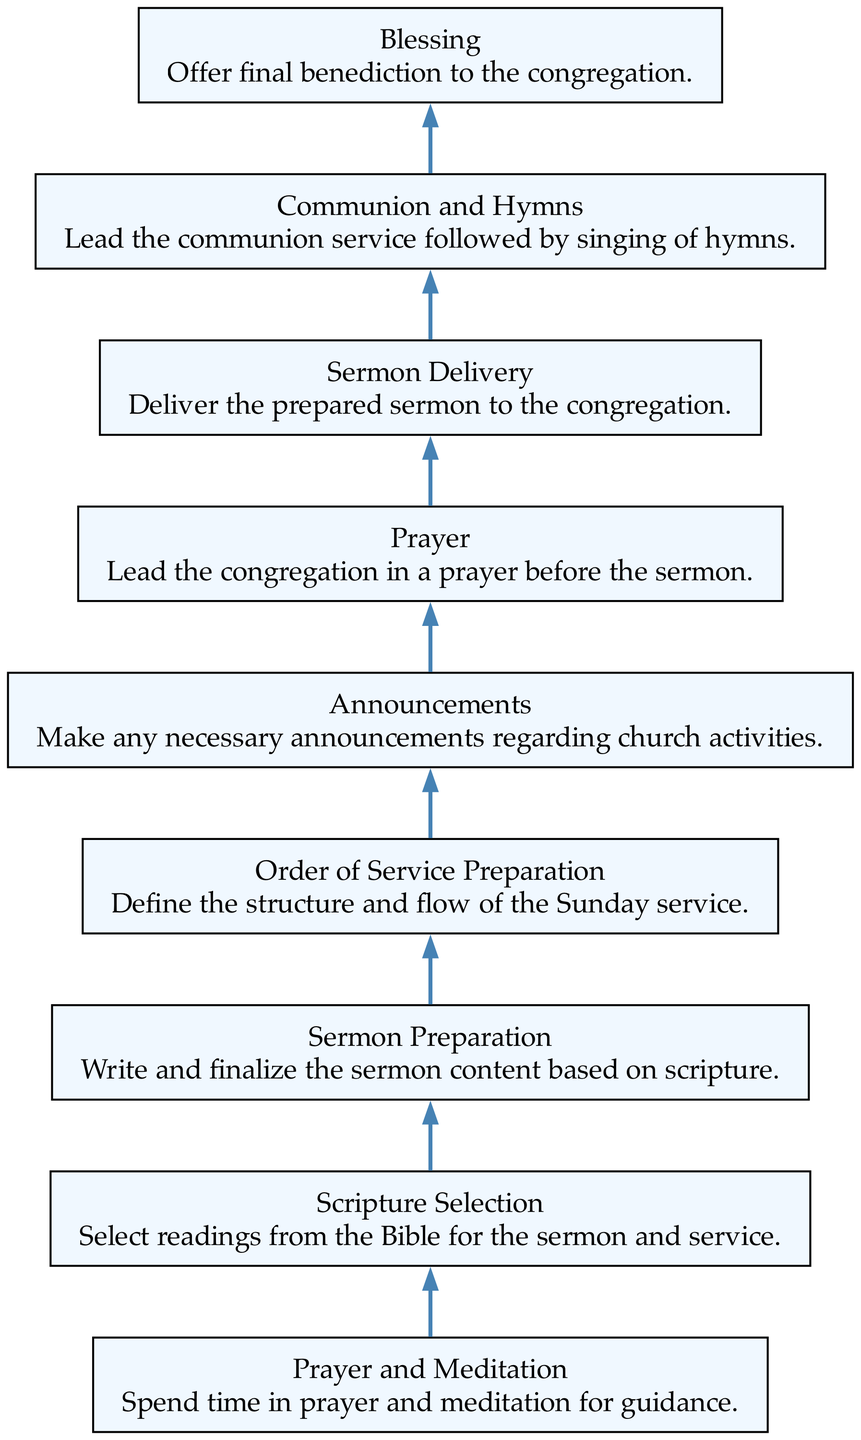What is the final stage in the preparation process? The diagram shows the stages of the Sunday Service Preparation, and the last node at the bottom indicates "Blessing." This is where the final benediction is offered to the congregation.
Answer: Blessing How many stages are listed in the diagram? By counting the nodes in the diagram from "Blessing" to "Prayer and Meditation," there are a total of 9 distinct stages included, indicating a clear flow of tasks.
Answer: 9 What task is associated with the "Sermon Delivery"? The diagram clearly outlines that during the "Sermon Delivery" stage, the task is to "Deliver the prepared sermon to the congregation." This direct relationship is indicated within the node for that stage.
Answer: Deliver the prepared sermon to the congregation What comes before the "Communion and Hymns"? In the flow of the diagram, the "Sermon Delivery" stage logically precedes the "Communion and Hymns" stage, showing the sequence of actions leading up to the music and communion after the sermon.
Answer: Sermon Delivery What is the purpose of "Order of Service Preparation"? The diagram specifies that "Order of Service Preparation" involves defining the structure and flow of the Sunday service, which is crucial for organizing the overall service effectively.
Answer: Define the structure and flow of the Sunday service Which task involves selecting Bible readings? By examining the stages in the diagram, it is clear that the "Scripture Selection" stage is specifically focused on selecting the readings from the Bible for the sermon and the service.
Answer: Select readings from the Bible for the sermon and service What is the step that follows "Prayer and Meditation"? The flow indicates that after the "Prayer and Meditation" stage, the next step is "Scripture Selection," illustrating the transition from personal reflection to the preparation of scripture readings.
Answer: Scripture Selection What is the relationship between "Prayer" and "Sermon Delivery"? The diagram shows that "Prayer" is positioned directly before "Sermon Delivery," which signifies that leading a prayer is a preparatory step that occurs to prepare the congregation for the sermon that will follow.
Answer: "Prayer" directly precedes "Sermon Delivery." How does "Announcements" fit into the service preparation? According to the diagram, "Announcements" is a dedicated stage where necessary information is communicated to the congregation regarding upcoming church activities, reflecting its significance in maintaining community knowledge and involvement.
Answer: Make any necessary announcements regarding church activities 